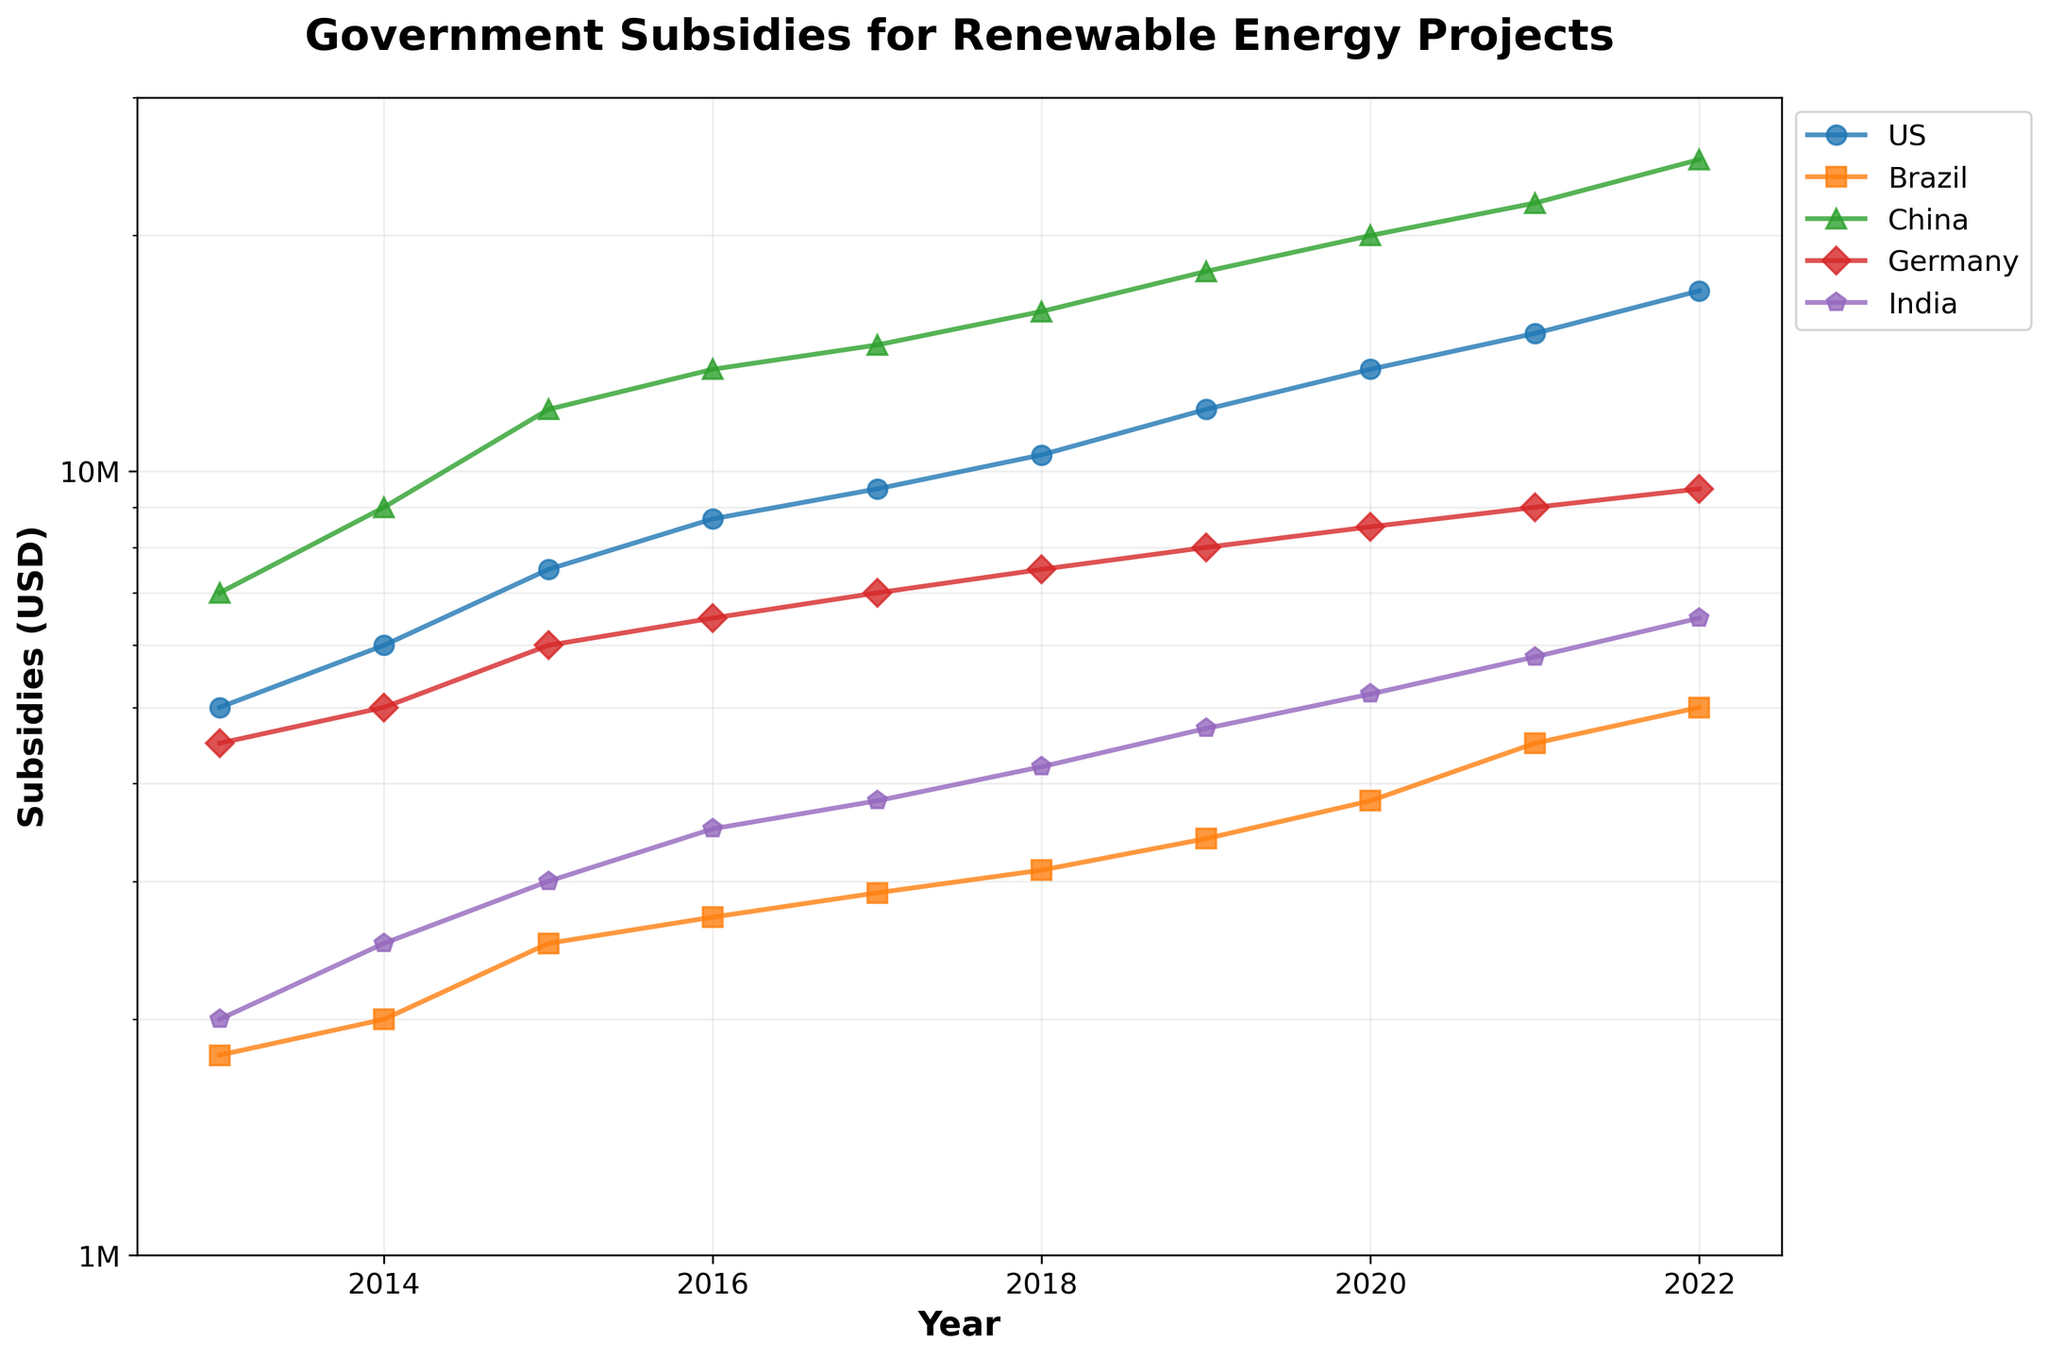what is the title of the figure? The title is usually located at the top of the figure. In this case, it reads "Government Subsidies for Renewable Energy Projects".
Answer: Government Subsidies for Renewable Energy Projects Which country had the highest subsidies in 2022? Look at the endpoint of each line corresponding to 2022, verify the one that has the highest value. The green line representing China is the highest.
Answer: China By how much did the subsidies in India increase from 2013 to 2022? Check the values for India in 2013 and 2022 from the y-axis respectively, then subtract the value of 2013 from 2022. The values are 2,000,000 and 6,500,000 respectively, so the increase is 6,500,000 - 2,000,000
Answer: 4,500,000 Which country's subsidies increased the most between 2013 and 2022? Compare the differences in subsidies for each country between 2013 and 2022. Calculate the differences as follows: 
- US: 17,000,000 - 5,000,000 = 12,000,000 
- Brazil: 5,000,000 - 1,800,000 = 3,200,000 
- China: 25,000,000 - 7,000,000 = 18,000,000 
- Germany: 9,500,000 - 4,500,000 = 5,000,000 
- India: 6,500,000 - 2,000,000 = 4,500,000 
China has the highest increase.
Answer: China Which year saw the highest increase in US subsidies compared to the previous year? Calculate the yearly increases for US subsidies and find the highest one: 
- 2014-2013: 6,000,000 - 5,000,000 = 1,000,000 
- 2015-2014: 7,500,000 - 6,000,000 = 1,500,000 
- 2016-2015: 8,700,000 - 7,500,000 = 1,200,000 
- 2017-2016: 9,500,000 - 8,700,000 = 800,000 
- 2018-2017: 10,500,000 - 9,500,000 = 1,000,000 
- 2019-2018: 12,000,000 - 10,500,000 = 1,500,000 
- 2020-2019: 13,500,000 - 12,000,000 = 1,500,000 
- 2021-2020: 15,000,000 - 13,500,000 = 1,500,000 
- 2022-2021: 17,000,000 - 15,000,000 = 2,000,000 
Year 2022 had the highest increase.
Answer: 2022 How many countries have subsidies exceeding 10 million USD in 2020? Identify the data points above 10 million USD on the y-axis in the year 2020. These are for US, China and Germany. 3 countries in total.
Answer: 3 What trend is visible in the subsidy data for Brazil? Look at the line plot for Brazil, represented by the data points over the years. It's consistently increasing without any reductions or flat periods.
Answer: Consistent Increase What is the y-axis range in the figure? The minimum and maximum values on the y-axis are specified to be from 1 million USD to 30 million USD respectively.
Answer: 1 million to 30 million USD 